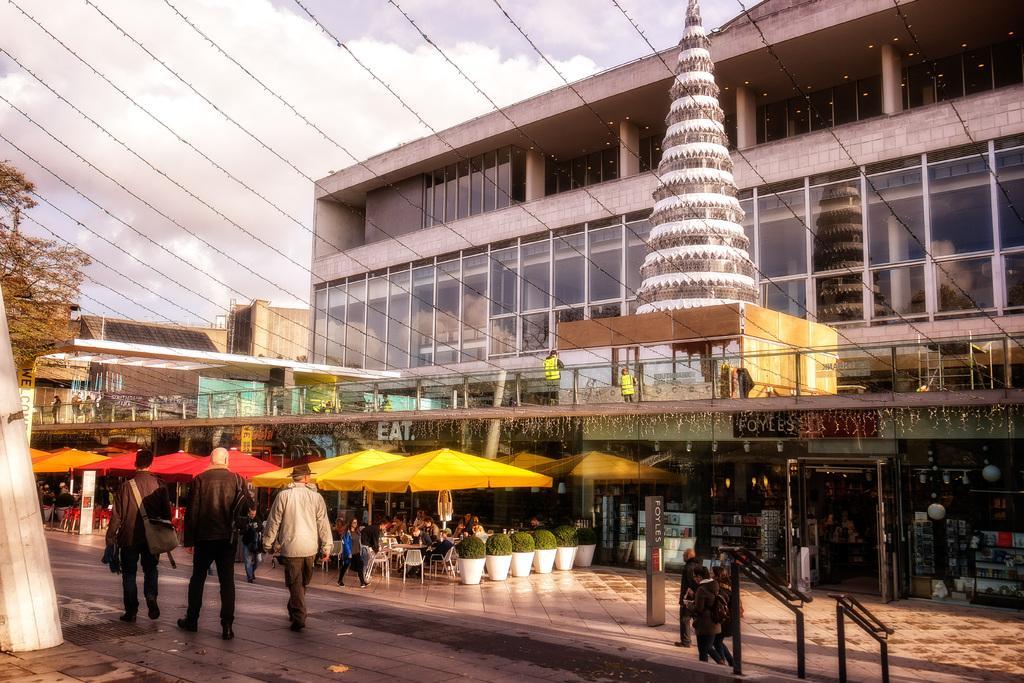How would you summarize this image in a sentence or two? In this image we can see some people walking, on the right side of the image there is a restaurant and there are some potted plants and people sitting in front of the restaurant and on the left side of the picture there is a tree and the sky in the background. 